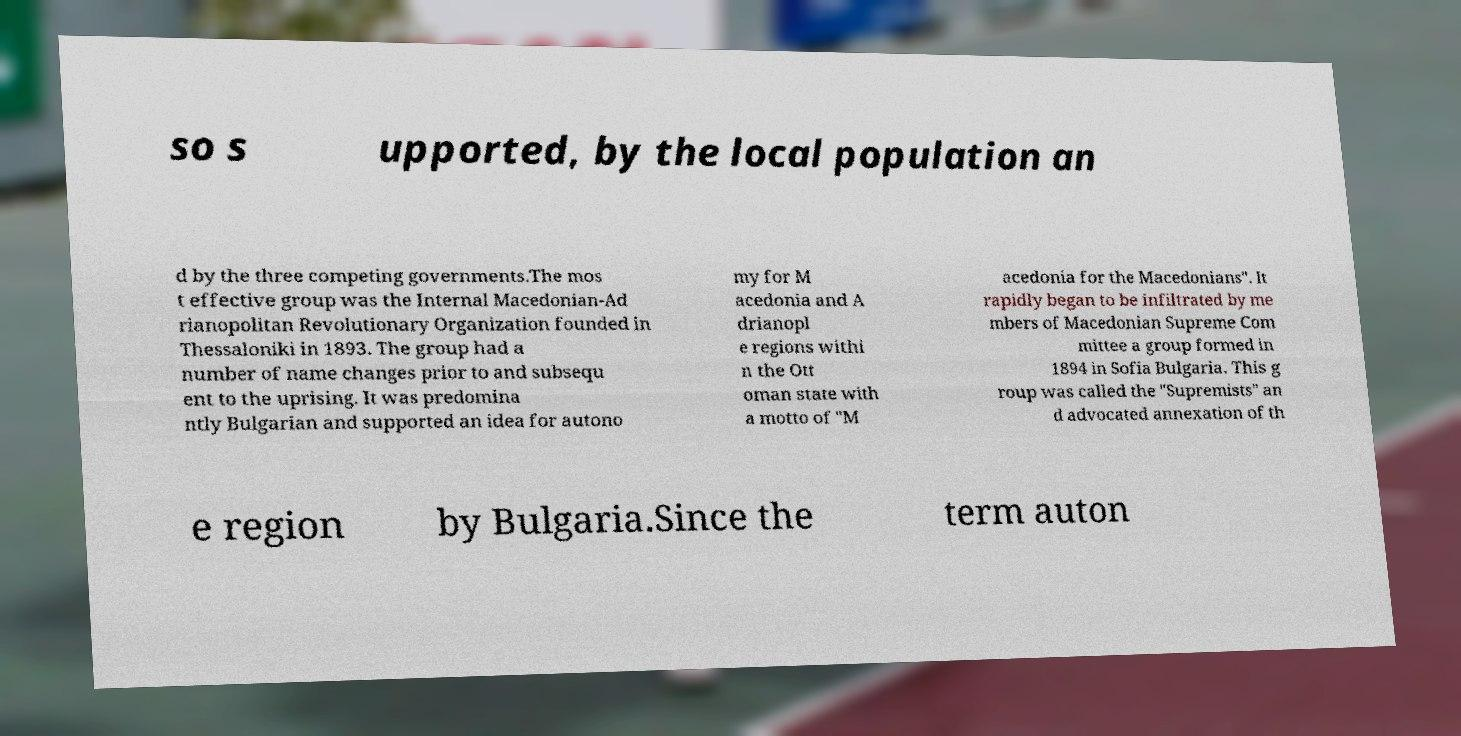I need the written content from this picture converted into text. Can you do that? so s upported, by the local population an d by the three competing governments.The mos t effective group was the Internal Macedonian-Ad rianopolitan Revolutionary Organization founded in Thessaloniki in 1893. The group had a number of name changes prior to and subsequ ent to the uprising. It was predomina ntly Bulgarian and supported an idea for autono my for M acedonia and A drianopl e regions withi n the Ott oman state with a motto of "M acedonia for the Macedonians". It rapidly began to be infiltrated by me mbers of Macedonian Supreme Com mittee a group formed in 1894 in Sofia Bulgaria. This g roup was called the "Supremists" an d advocated annexation of th e region by Bulgaria.Since the term auton 